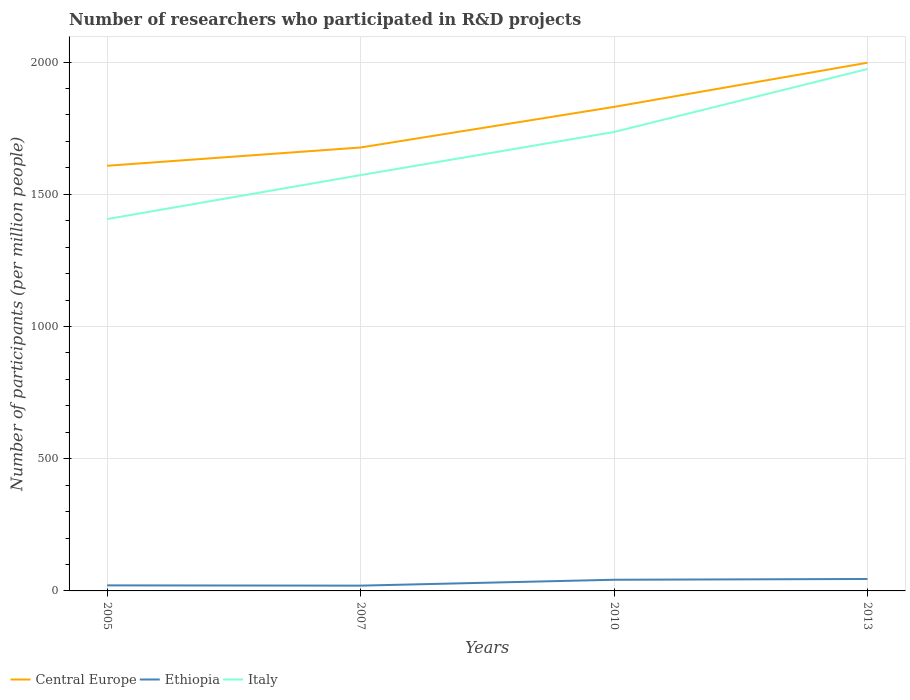Does the line corresponding to Ethiopia intersect with the line corresponding to Italy?
Keep it short and to the point. No. Is the number of lines equal to the number of legend labels?
Give a very brief answer. Yes. Across all years, what is the maximum number of researchers who participated in R&D projects in Ethiopia?
Your response must be concise. 19.96. In which year was the number of researchers who participated in R&D projects in Central Europe maximum?
Offer a very short reply. 2005. What is the total number of researchers who participated in R&D projects in Central Europe in the graph?
Your answer should be very brief. -69.1. What is the difference between the highest and the second highest number of researchers who participated in R&D projects in Italy?
Make the answer very short. 567.47. What is the difference between the highest and the lowest number of researchers who participated in R&D projects in Italy?
Ensure brevity in your answer.  2. What is the difference between two consecutive major ticks on the Y-axis?
Offer a terse response. 500. Does the graph contain grids?
Provide a succinct answer. Yes. How are the legend labels stacked?
Provide a succinct answer. Horizontal. What is the title of the graph?
Give a very brief answer. Number of researchers who participated in R&D projects. What is the label or title of the Y-axis?
Your answer should be compact. Number of participants (per million people). What is the Number of participants (per million people) in Central Europe in 2005?
Give a very brief answer. 1607.88. What is the Number of participants (per million people) of Ethiopia in 2005?
Give a very brief answer. 20.99. What is the Number of participants (per million people) of Italy in 2005?
Offer a terse response. 1406.28. What is the Number of participants (per million people) of Central Europe in 2007?
Provide a short and direct response. 1676.99. What is the Number of participants (per million people) of Ethiopia in 2007?
Provide a succinct answer. 19.96. What is the Number of participants (per million people) of Italy in 2007?
Your answer should be very brief. 1572.58. What is the Number of participants (per million people) in Central Europe in 2010?
Ensure brevity in your answer.  1830.56. What is the Number of participants (per million people) of Ethiopia in 2010?
Make the answer very short. 42.27. What is the Number of participants (per million people) of Italy in 2010?
Ensure brevity in your answer.  1735.66. What is the Number of participants (per million people) in Central Europe in 2013?
Provide a short and direct response. 1997.6. What is the Number of participants (per million people) of Ethiopia in 2013?
Offer a very short reply. 45.12. What is the Number of participants (per million people) of Italy in 2013?
Offer a very short reply. 1973.75. Across all years, what is the maximum Number of participants (per million people) in Central Europe?
Keep it short and to the point. 1997.6. Across all years, what is the maximum Number of participants (per million people) of Ethiopia?
Your response must be concise. 45.12. Across all years, what is the maximum Number of participants (per million people) in Italy?
Offer a very short reply. 1973.75. Across all years, what is the minimum Number of participants (per million people) of Central Europe?
Keep it short and to the point. 1607.88. Across all years, what is the minimum Number of participants (per million people) of Ethiopia?
Provide a short and direct response. 19.96. Across all years, what is the minimum Number of participants (per million people) of Italy?
Make the answer very short. 1406.28. What is the total Number of participants (per million people) of Central Europe in the graph?
Offer a very short reply. 7113.03. What is the total Number of participants (per million people) of Ethiopia in the graph?
Your answer should be very brief. 128.34. What is the total Number of participants (per million people) of Italy in the graph?
Provide a short and direct response. 6688.27. What is the difference between the Number of participants (per million people) in Central Europe in 2005 and that in 2007?
Provide a short and direct response. -69.1. What is the difference between the Number of participants (per million people) of Italy in 2005 and that in 2007?
Offer a very short reply. -166.29. What is the difference between the Number of participants (per million people) of Central Europe in 2005 and that in 2010?
Provide a short and direct response. -222.67. What is the difference between the Number of participants (per million people) in Ethiopia in 2005 and that in 2010?
Make the answer very short. -21.28. What is the difference between the Number of participants (per million people) of Italy in 2005 and that in 2010?
Provide a short and direct response. -329.37. What is the difference between the Number of participants (per million people) in Central Europe in 2005 and that in 2013?
Provide a succinct answer. -389.72. What is the difference between the Number of participants (per million people) in Ethiopia in 2005 and that in 2013?
Provide a succinct answer. -24.13. What is the difference between the Number of participants (per million people) of Italy in 2005 and that in 2013?
Provide a succinct answer. -567.47. What is the difference between the Number of participants (per million people) in Central Europe in 2007 and that in 2010?
Keep it short and to the point. -153.57. What is the difference between the Number of participants (per million people) of Ethiopia in 2007 and that in 2010?
Keep it short and to the point. -22.3. What is the difference between the Number of participants (per million people) in Italy in 2007 and that in 2010?
Your response must be concise. -163.08. What is the difference between the Number of participants (per million people) in Central Europe in 2007 and that in 2013?
Ensure brevity in your answer.  -320.61. What is the difference between the Number of participants (per million people) in Ethiopia in 2007 and that in 2013?
Provide a short and direct response. -25.16. What is the difference between the Number of participants (per million people) in Italy in 2007 and that in 2013?
Offer a very short reply. -401.17. What is the difference between the Number of participants (per million people) in Central Europe in 2010 and that in 2013?
Your answer should be compact. -167.05. What is the difference between the Number of participants (per million people) of Ethiopia in 2010 and that in 2013?
Make the answer very short. -2.86. What is the difference between the Number of participants (per million people) in Italy in 2010 and that in 2013?
Make the answer very short. -238.09. What is the difference between the Number of participants (per million people) of Central Europe in 2005 and the Number of participants (per million people) of Ethiopia in 2007?
Your response must be concise. 1587.92. What is the difference between the Number of participants (per million people) in Central Europe in 2005 and the Number of participants (per million people) in Italy in 2007?
Ensure brevity in your answer.  35.31. What is the difference between the Number of participants (per million people) of Ethiopia in 2005 and the Number of participants (per million people) of Italy in 2007?
Offer a very short reply. -1551.59. What is the difference between the Number of participants (per million people) in Central Europe in 2005 and the Number of participants (per million people) in Ethiopia in 2010?
Make the answer very short. 1565.62. What is the difference between the Number of participants (per million people) of Central Europe in 2005 and the Number of participants (per million people) of Italy in 2010?
Your response must be concise. -127.77. What is the difference between the Number of participants (per million people) of Ethiopia in 2005 and the Number of participants (per million people) of Italy in 2010?
Give a very brief answer. -1714.67. What is the difference between the Number of participants (per million people) of Central Europe in 2005 and the Number of participants (per million people) of Ethiopia in 2013?
Give a very brief answer. 1562.76. What is the difference between the Number of participants (per million people) of Central Europe in 2005 and the Number of participants (per million people) of Italy in 2013?
Offer a very short reply. -365.87. What is the difference between the Number of participants (per million people) of Ethiopia in 2005 and the Number of participants (per million people) of Italy in 2013?
Your answer should be compact. -1952.76. What is the difference between the Number of participants (per million people) in Central Europe in 2007 and the Number of participants (per million people) in Ethiopia in 2010?
Offer a very short reply. 1634.72. What is the difference between the Number of participants (per million people) of Central Europe in 2007 and the Number of participants (per million people) of Italy in 2010?
Give a very brief answer. -58.67. What is the difference between the Number of participants (per million people) of Ethiopia in 2007 and the Number of participants (per million people) of Italy in 2010?
Your answer should be very brief. -1715.69. What is the difference between the Number of participants (per million people) of Central Europe in 2007 and the Number of participants (per million people) of Ethiopia in 2013?
Your answer should be very brief. 1631.87. What is the difference between the Number of participants (per million people) in Central Europe in 2007 and the Number of participants (per million people) in Italy in 2013?
Offer a terse response. -296.76. What is the difference between the Number of participants (per million people) of Ethiopia in 2007 and the Number of participants (per million people) of Italy in 2013?
Your answer should be compact. -1953.79. What is the difference between the Number of participants (per million people) in Central Europe in 2010 and the Number of participants (per million people) in Ethiopia in 2013?
Your answer should be very brief. 1785.43. What is the difference between the Number of participants (per million people) in Central Europe in 2010 and the Number of participants (per million people) in Italy in 2013?
Keep it short and to the point. -143.2. What is the difference between the Number of participants (per million people) in Ethiopia in 2010 and the Number of participants (per million people) in Italy in 2013?
Provide a short and direct response. -1931.48. What is the average Number of participants (per million people) in Central Europe per year?
Offer a terse response. 1778.26. What is the average Number of participants (per million people) in Ethiopia per year?
Ensure brevity in your answer.  32.09. What is the average Number of participants (per million people) in Italy per year?
Keep it short and to the point. 1672.07. In the year 2005, what is the difference between the Number of participants (per million people) in Central Europe and Number of participants (per million people) in Ethiopia?
Offer a terse response. 1586.89. In the year 2005, what is the difference between the Number of participants (per million people) of Central Europe and Number of participants (per million people) of Italy?
Provide a succinct answer. 201.6. In the year 2005, what is the difference between the Number of participants (per million people) of Ethiopia and Number of participants (per million people) of Italy?
Your answer should be compact. -1385.29. In the year 2007, what is the difference between the Number of participants (per million people) in Central Europe and Number of participants (per million people) in Ethiopia?
Offer a very short reply. 1657.02. In the year 2007, what is the difference between the Number of participants (per million people) of Central Europe and Number of participants (per million people) of Italy?
Offer a terse response. 104.41. In the year 2007, what is the difference between the Number of participants (per million people) of Ethiopia and Number of participants (per million people) of Italy?
Offer a very short reply. -1552.61. In the year 2010, what is the difference between the Number of participants (per million people) in Central Europe and Number of participants (per million people) in Ethiopia?
Provide a succinct answer. 1788.29. In the year 2010, what is the difference between the Number of participants (per million people) in Central Europe and Number of participants (per million people) in Italy?
Ensure brevity in your answer.  94.9. In the year 2010, what is the difference between the Number of participants (per million people) in Ethiopia and Number of participants (per million people) in Italy?
Keep it short and to the point. -1693.39. In the year 2013, what is the difference between the Number of participants (per million people) of Central Europe and Number of participants (per million people) of Ethiopia?
Ensure brevity in your answer.  1952.48. In the year 2013, what is the difference between the Number of participants (per million people) of Central Europe and Number of participants (per million people) of Italy?
Your answer should be compact. 23.85. In the year 2013, what is the difference between the Number of participants (per million people) in Ethiopia and Number of participants (per million people) in Italy?
Provide a short and direct response. -1928.63. What is the ratio of the Number of participants (per million people) in Central Europe in 2005 to that in 2007?
Make the answer very short. 0.96. What is the ratio of the Number of participants (per million people) of Ethiopia in 2005 to that in 2007?
Your answer should be compact. 1.05. What is the ratio of the Number of participants (per million people) of Italy in 2005 to that in 2007?
Keep it short and to the point. 0.89. What is the ratio of the Number of participants (per million people) in Central Europe in 2005 to that in 2010?
Provide a short and direct response. 0.88. What is the ratio of the Number of participants (per million people) of Ethiopia in 2005 to that in 2010?
Give a very brief answer. 0.5. What is the ratio of the Number of participants (per million people) of Italy in 2005 to that in 2010?
Give a very brief answer. 0.81. What is the ratio of the Number of participants (per million people) in Central Europe in 2005 to that in 2013?
Provide a short and direct response. 0.8. What is the ratio of the Number of participants (per million people) in Ethiopia in 2005 to that in 2013?
Offer a terse response. 0.47. What is the ratio of the Number of participants (per million people) of Italy in 2005 to that in 2013?
Give a very brief answer. 0.71. What is the ratio of the Number of participants (per million people) of Central Europe in 2007 to that in 2010?
Offer a very short reply. 0.92. What is the ratio of the Number of participants (per million people) in Ethiopia in 2007 to that in 2010?
Provide a succinct answer. 0.47. What is the ratio of the Number of participants (per million people) of Italy in 2007 to that in 2010?
Give a very brief answer. 0.91. What is the ratio of the Number of participants (per million people) in Central Europe in 2007 to that in 2013?
Ensure brevity in your answer.  0.84. What is the ratio of the Number of participants (per million people) in Ethiopia in 2007 to that in 2013?
Your response must be concise. 0.44. What is the ratio of the Number of participants (per million people) of Italy in 2007 to that in 2013?
Your answer should be compact. 0.8. What is the ratio of the Number of participants (per million people) of Central Europe in 2010 to that in 2013?
Provide a short and direct response. 0.92. What is the ratio of the Number of participants (per million people) in Ethiopia in 2010 to that in 2013?
Keep it short and to the point. 0.94. What is the ratio of the Number of participants (per million people) in Italy in 2010 to that in 2013?
Offer a terse response. 0.88. What is the difference between the highest and the second highest Number of participants (per million people) of Central Europe?
Keep it short and to the point. 167.05. What is the difference between the highest and the second highest Number of participants (per million people) in Ethiopia?
Offer a terse response. 2.86. What is the difference between the highest and the second highest Number of participants (per million people) in Italy?
Offer a very short reply. 238.09. What is the difference between the highest and the lowest Number of participants (per million people) in Central Europe?
Offer a very short reply. 389.72. What is the difference between the highest and the lowest Number of participants (per million people) in Ethiopia?
Your response must be concise. 25.16. What is the difference between the highest and the lowest Number of participants (per million people) in Italy?
Your answer should be compact. 567.47. 